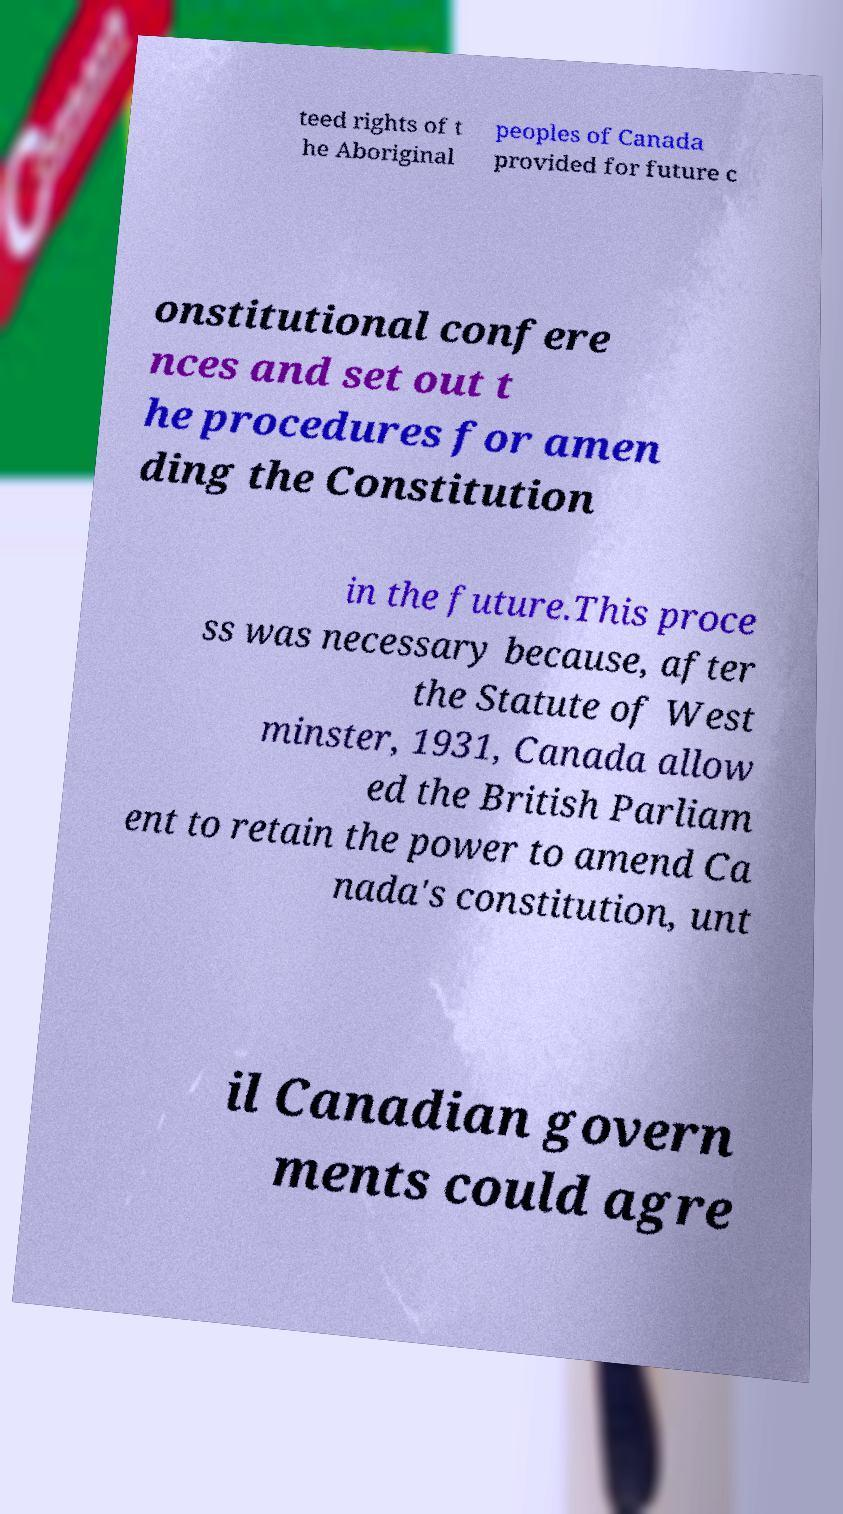There's text embedded in this image that I need extracted. Can you transcribe it verbatim? teed rights of t he Aboriginal peoples of Canada provided for future c onstitutional confere nces and set out t he procedures for amen ding the Constitution in the future.This proce ss was necessary because, after the Statute of West minster, 1931, Canada allow ed the British Parliam ent to retain the power to amend Ca nada's constitution, unt il Canadian govern ments could agre 